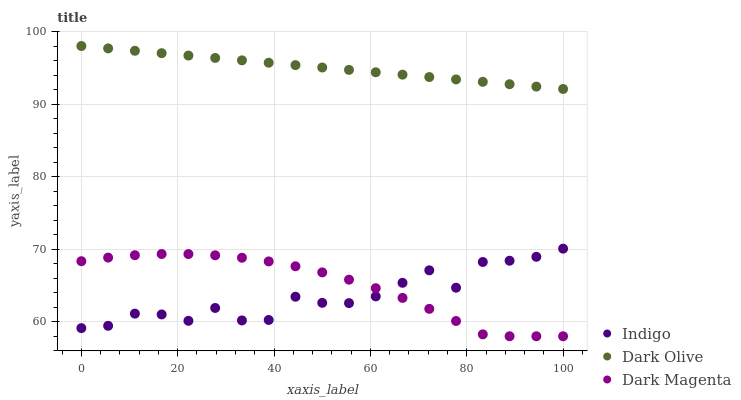Does Indigo have the minimum area under the curve?
Answer yes or no. Yes. Does Dark Olive have the maximum area under the curve?
Answer yes or no. Yes. Does Dark Magenta have the minimum area under the curve?
Answer yes or no. No. Does Dark Magenta have the maximum area under the curve?
Answer yes or no. No. Is Dark Olive the smoothest?
Answer yes or no. Yes. Is Indigo the roughest?
Answer yes or no. Yes. Is Dark Magenta the smoothest?
Answer yes or no. No. Is Dark Magenta the roughest?
Answer yes or no. No. Does Dark Magenta have the lowest value?
Answer yes or no. Yes. Does Indigo have the lowest value?
Answer yes or no. No. Does Dark Olive have the highest value?
Answer yes or no. Yes. Does Indigo have the highest value?
Answer yes or no. No. Is Dark Magenta less than Dark Olive?
Answer yes or no. Yes. Is Dark Olive greater than Dark Magenta?
Answer yes or no. Yes. Does Indigo intersect Dark Magenta?
Answer yes or no. Yes. Is Indigo less than Dark Magenta?
Answer yes or no. No. Is Indigo greater than Dark Magenta?
Answer yes or no. No. Does Dark Magenta intersect Dark Olive?
Answer yes or no. No. 